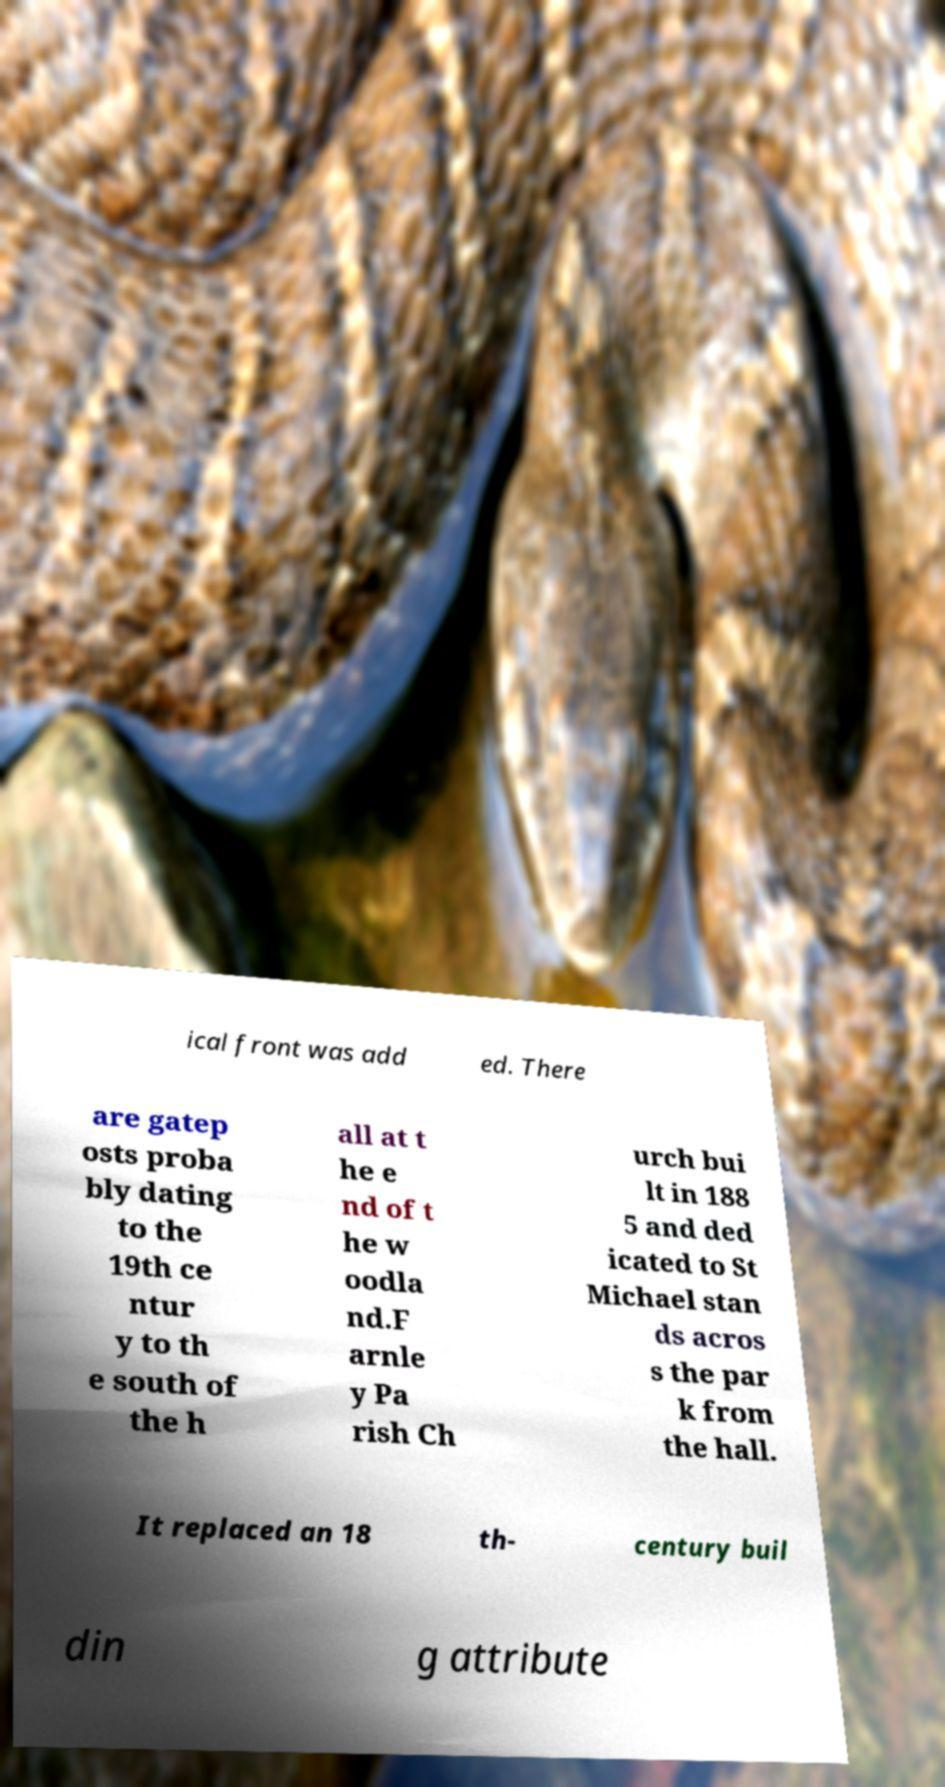I need the written content from this picture converted into text. Can you do that? ical front was add ed. There are gatep osts proba bly dating to the 19th ce ntur y to th e south of the h all at t he e nd of t he w oodla nd.F arnle y Pa rish Ch urch bui lt in 188 5 and ded icated to St Michael stan ds acros s the par k from the hall. It replaced an 18 th- century buil din g attribute 